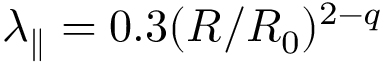<formula> <loc_0><loc_0><loc_500><loc_500>\lambda _ { \| } = 0 . 3 ( R / R _ { 0 } ) ^ { 2 - q }</formula> 